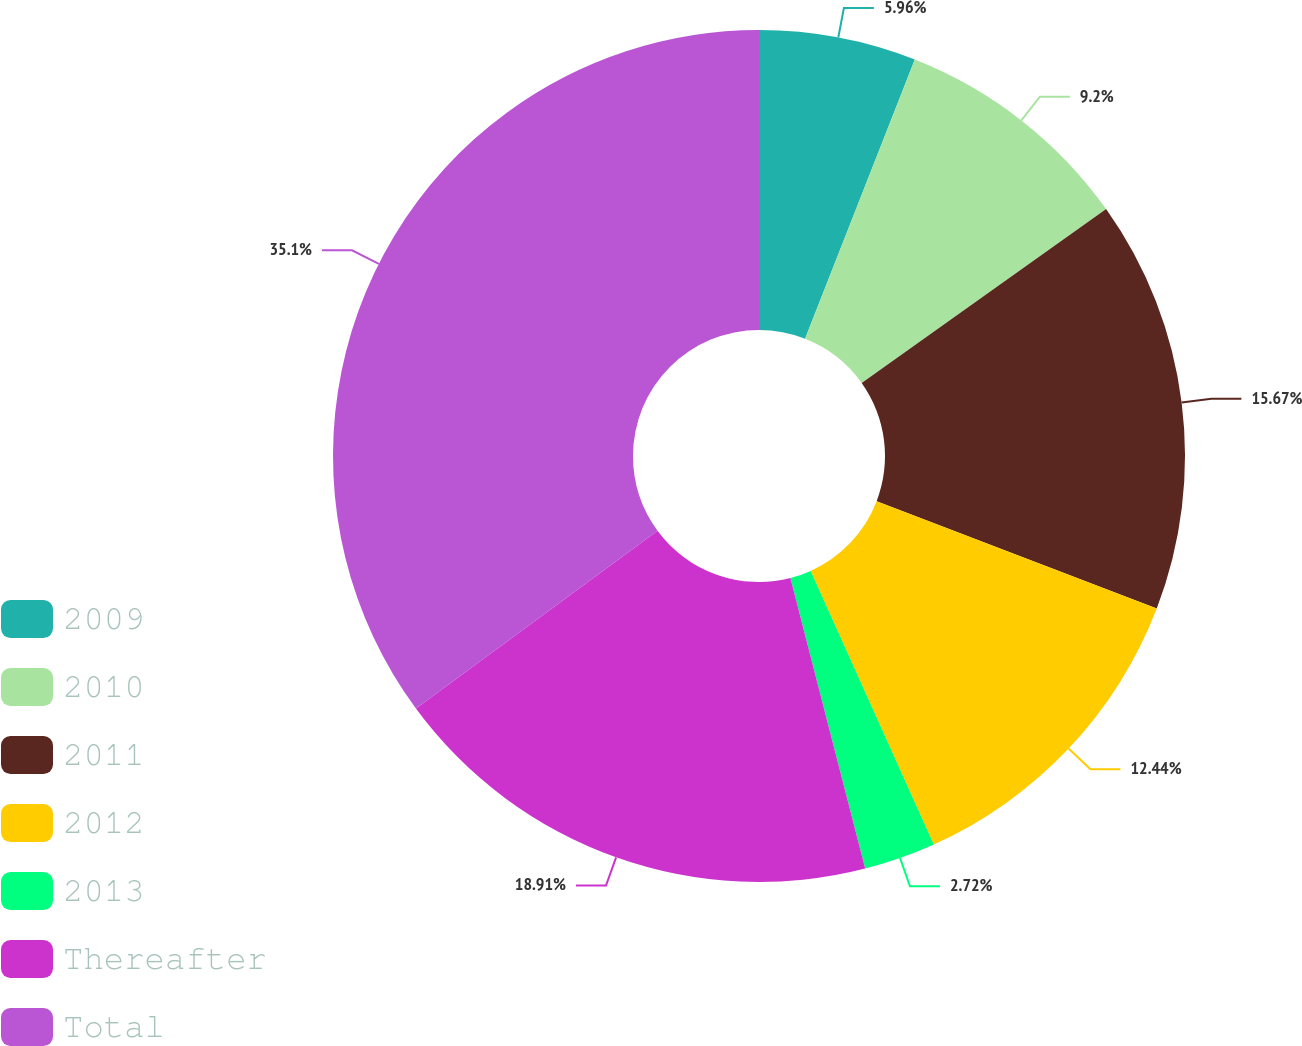Convert chart. <chart><loc_0><loc_0><loc_500><loc_500><pie_chart><fcel>2009<fcel>2010<fcel>2011<fcel>2012<fcel>2013<fcel>Thereafter<fcel>Total<nl><fcel>5.96%<fcel>9.2%<fcel>15.67%<fcel>12.44%<fcel>2.72%<fcel>18.91%<fcel>35.1%<nl></chart> 